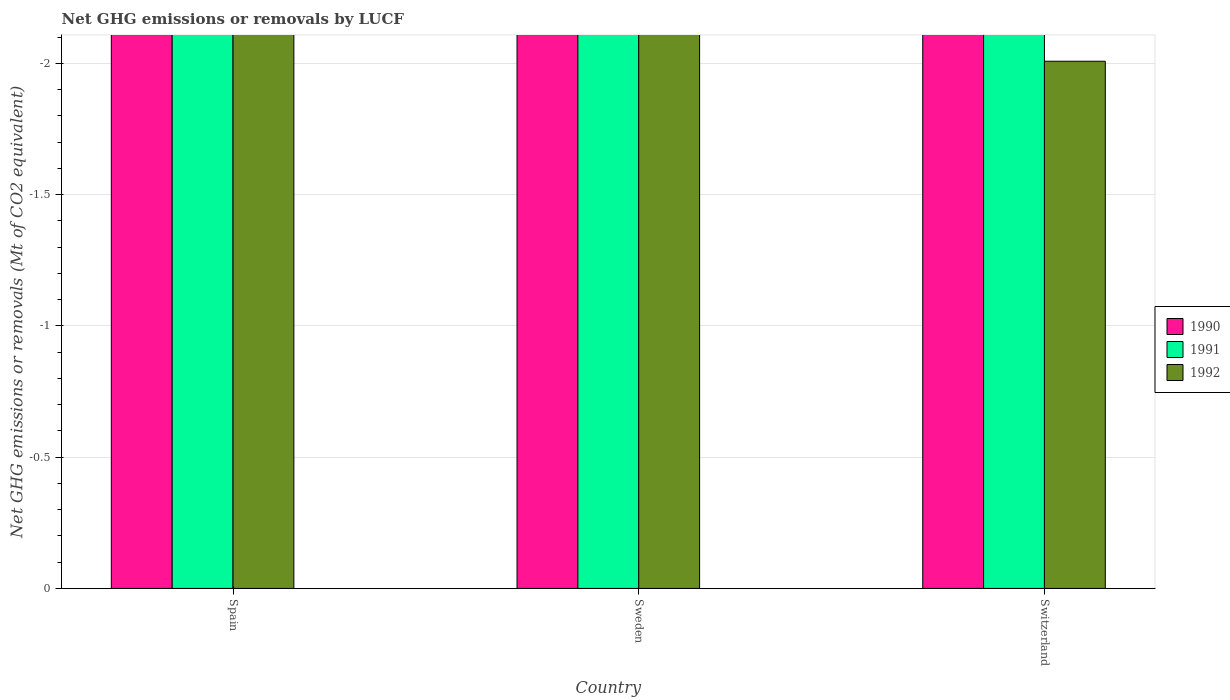How many different coloured bars are there?
Give a very brief answer. 0. How many bars are there on the 1st tick from the left?
Keep it short and to the point. 0. How many bars are there on the 3rd tick from the right?
Your answer should be very brief. 0. What is the label of the 1st group of bars from the left?
Your answer should be compact. Spain. In how many cases, is the number of bars for a given country not equal to the number of legend labels?
Your answer should be very brief. 3. What is the net GHG emissions or removals by LUCF in 1991 in Spain?
Provide a succinct answer. 0. Across all countries, what is the minimum net GHG emissions or removals by LUCF in 1992?
Your response must be concise. 0. In how many countries, is the net GHG emissions or removals by LUCF in 1992 greater than the average net GHG emissions or removals by LUCF in 1992 taken over all countries?
Your answer should be very brief. 0. How many bars are there?
Your answer should be very brief. 0. Are all the bars in the graph horizontal?
Give a very brief answer. No. How many countries are there in the graph?
Provide a short and direct response. 3. What is the difference between two consecutive major ticks on the Y-axis?
Give a very brief answer. 0.5. Does the graph contain any zero values?
Provide a short and direct response. Yes. Where does the legend appear in the graph?
Ensure brevity in your answer.  Center right. How many legend labels are there?
Your answer should be very brief. 3. What is the title of the graph?
Make the answer very short. Net GHG emissions or removals by LUCF. What is the label or title of the X-axis?
Provide a succinct answer. Country. What is the label or title of the Y-axis?
Ensure brevity in your answer.  Net GHG emissions or removals (Mt of CO2 equivalent). What is the Net GHG emissions or removals (Mt of CO2 equivalent) of 1990 in Spain?
Give a very brief answer. 0. What is the Net GHG emissions or removals (Mt of CO2 equivalent) of 1992 in Spain?
Make the answer very short. 0. What is the Net GHG emissions or removals (Mt of CO2 equivalent) in 1990 in Sweden?
Provide a succinct answer. 0. What is the Net GHG emissions or removals (Mt of CO2 equivalent) in 1992 in Sweden?
Offer a terse response. 0. What is the Net GHG emissions or removals (Mt of CO2 equivalent) in 1990 in Switzerland?
Offer a terse response. 0. What is the Net GHG emissions or removals (Mt of CO2 equivalent) in 1991 in Switzerland?
Provide a short and direct response. 0. What is the Net GHG emissions or removals (Mt of CO2 equivalent) in 1992 in Switzerland?
Keep it short and to the point. 0. What is the total Net GHG emissions or removals (Mt of CO2 equivalent) of 1990 in the graph?
Ensure brevity in your answer.  0. What is the total Net GHG emissions or removals (Mt of CO2 equivalent) in 1991 in the graph?
Ensure brevity in your answer.  0. What is the total Net GHG emissions or removals (Mt of CO2 equivalent) of 1992 in the graph?
Your answer should be very brief. 0. What is the average Net GHG emissions or removals (Mt of CO2 equivalent) of 1990 per country?
Provide a succinct answer. 0. What is the average Net GHG emissions or removals (Mt of CO2 equivalent) in 1991 per country?
Provide a short and direct response. 0. What is the average Net GHG emissions or removals (Mt of CO2 equivalent) of 1992 per country?
Offer a very short reply. 0. 